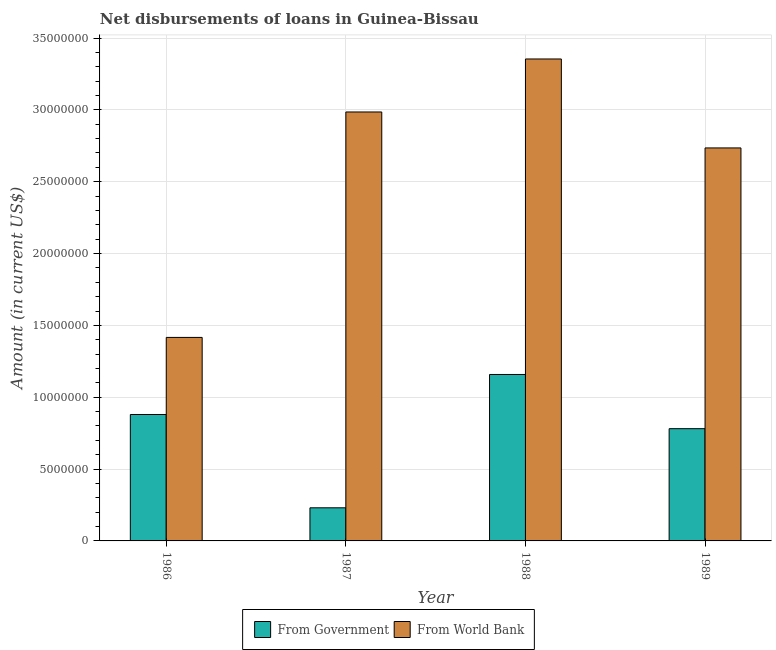Are the number of bars on each tick of the X-axis equal?
Provide a short and direct response. Yes. How many bars are there on the 4th tick from the left?
Your response must be concise. 2. How many bars are there on the 2nd tick from the right?
Give a very brief answer. 2. In how many cases, is the number of bars for a given year not equal to the number of legend labels?
Ensure brevity in your answer.  0. What is the net disbursements of loan from government in 1989?
Keep it short and to the point. 7.81e+06. Across all years, what is the maximum net disbursements of loan from world bank?
Your answer should be very brief. 3.35e+07. Across all years, what is the minimum net disbursements of loan from world bank?
Your answer should be compact. 1.42e+07. What is the total net disbursements of loan from government in the graph?
Your answer should be compact. 3.05e+07. What is the difference between the net disbursements of loan from government in 1987 and that in 1988?
Your answer should be compact. -9.28e+06. What is the difference between the net disbursements of loan from world bank in 1989 and the net disbursements of loan from government in 1986?
Make the answer very short. 1.32e+07. What is the average net disbursements of loan from government per year?
Provide a succinct answer. 7.62e+06. In the year 1987, what is the difference between the net disbursements of loan from world bank and net disbursements of loan from government?
Your answer should be compact. 0. In how many years, is the net disbursements of loan from world bank greater than 14000000 US$?
Your answer should be very brief. 4. What is the ratio of the net disbursements of loan from world bank in 1986 to that in 1989?
Make the answer very short. 0.52. Is the net disbursements of loan from world bank in 1986 less than that in 1988?
Offer a terse response. Yes. Is the difference between the net disbursements of loan from world bank in 1987 and 1989 greater than the difference between the net disbursements of loan from government in 1987 and 1989?
Make the answer very short. No. What is the difference between the highest and the second highest net disbursements of loan from world bank?
Provide a succinct answer. 3.69e+06. What is the difference between the highest and the lowest net disbursements of loan from government?
Give a very brief answer. 9.28e+06. In how many years, is the net disbursements of loan from government greater than the average net disbursements of loan from government taken over all years?
Make the answer very short. 3. Is the sum of the net disbursements of loan from world bank in 1987 and 1989 greater than the maximum net disbursements of loan from government across all years?
Ensure brevity in your answer.  Yes. What does the 1st bar from the left in 1989 represents?
Provide a succinct answer. From Government. What does the 2nd bar from the right in 1989 represents?
Provide a short and direct response. From Government. How many bars are there?
Ensure brevity in your answer.  8. Are all the bars in the graph horizontal?
Give a very brief answer. No. Where does the legend appear in the graph?
Ensure brevity in your answer.  Bottom center. How are the legend labels stacked?
Your answer should be compact. Horizontal. What is the title of the graph?
Offer a very short reply. Net disbursements of loans in Guinea-Bissau. What is the label or title of the Y-axis?
Offer a very short reply. Amount (in current US$). What is the Amount (in current US$) in From Government in 1986?
Offer a very short reply. 8.80e+06. What is the Amount (in current US$) in From World Bank in 1986?
Your response must be concise. 1.42e+07. What is the Amount (in current US$) of From Government in 1987?
Provide a succinct answer. 2.30e+06. What is the Amount (in current US$) of From World Bank in 1987?
Provide a short and direct response. 2.99e+07. What is the Amount (in current US$) of From Government in 1988?
Your answer should be very brief. 1.16e+07. What is the Amount (in current US$) in From World Bank in 1988?
Offer a terse response. 3.35e+07. What is the Amount (in current US$) in From Government in 1989?
Your answer should be compact. 7.81e+06. What is the Amount (in current US$) of From World Bank in 1989?
Your answer should be compact. 2.74e+07. Across all years, what is the maximum Amount (in current US$) of From Government?
Keep it short and to the point. 1.16e+07. Across all years, what is the maximum Amount (in current US$) of From World Bank?
Ensure brevity in your answer.  3.35e+07. Across all years, what is the minimum Amount (in current US$) of From Government?
Provide a short and direct response. 2.30e+06. Across all years, what is the minimum Amount (in current US$) of From World Bank?
Your answer should be very brief. 1.42e+07. What is the total Amount (in current US$) of From Government in the graph?
Give a very brief answer. 3.05e+07. What is the total Amount (in current US$) of From World Bank in the graph?
Give a very brief answer. 1.05e+08. What is the difference between the Amount (in current US$) of From Government in 1986 and that in 1987?
Ensure brevity in your answer.  6.49e+06. What is the difference between the Amount (in current US$) in From World Bank in 1986 and that in 1987?
Keep it short and to the point. -1.57e+07. What is the difference between the Amount (in current US$) of From Government in 1986 and that in 1988?
Keep it short and to the point. -2.79e+06. What is the difference between the Amount (in current US$) in From World Bank in 1986 and that in 1988?
Your answer should be very brief. -1.94e+07. What is the difference between the Amount (in current US$) of From Government in 1986 and that in 1989?
Provide a short and direct response. 9.87e+05. What is the difference between the Amount (in current US$) in From World Bank in 1986 and that in 1989?
Offer a very short reply. -1.32e+07. What is the difference between the Amount (in current US$) of From Government in 1987 and that in 1988?
Provide a succinct answer. -9.28e+06. What is the difference between the Amount (in current US$) of From World Bank in 1987 and that in 1988?
Ensure brevity in your answer.  -3.69e+06. What is the difference between the Amount (in current US$) of From Government in 1987 and that in 1989?
Keep it short and to the point. -5.51e+06. What is the difference between the Amount (in current US$) in From World Bank in 1987 and that in 1989?
Your response must be concise. 2.50e+06. What is the difference between the Amount (in current US$) of From Government in 1988 and that in 1989?
Offer a very short reply. 3.77e+06. What is the difference between the Amount (in current US$) in From World Bank in 1988 and that in 1989?
Give a very brief answer. 6.19e+06. What is the difference between the Amount (in current US$) of From Government in 1986 and the Amount (in current US$) of From World Bank in 1987?
Your answer should be compact. -2.11e+07. What is the difference between the Amount (in current US$) of From Government in 1986 and the Amount (in current US$) of From World Bank in 1988?
Your answer should be compact. -2.47e+07. What is the difference between the Amount (in current US$) in From Government in 1986 and the Amount (in current US$) in From World Bank in 1989?
Provide a short and direct response. -1.86e+07. What is the difference between the Amount (in current US$) in From Government in 1987 and the Amount (in current US$) in From World Bank in 1988?
Ensure brevity in your answer.  -3.12e+07. What is the difference between the Amount (in current US$) of From Government in 1987 and the Amount (in current US$) of From World Bank in 1989?
Offer a very short reply. -2.50e+07. What is the difference between the Amount (in current US$) in From Government in 1988 and the Amount (in current US$) in From World Bank in 1989?
Your answer should be compact. -1.58e+07. What is the average Amount (in current US$) of From Government per year?
Keep it short and to the point. 7.62e+06. What is the average Amount (in current US$) in From World Bank per year?
Your response must be concise. 2.62e+07. In the year 1986, what is the difference between the Amount (in current US$) of From Government and Amount (in current US$) of From World Bank?
Keep it short and to the point. -5.36e+06. In the year 1987, what is the difference between the Amount (in current US$) of From Government and Amount (in current US$) of From World Bank?
Keep it short and to the point. -2.75e+07. In the year 1988, what is the difference between the Amount (in current US$) in From Government and Amount (in current US$) in From World Bank?
Provide a succinct answer. -2.20e+07. In the year 1989, what is the difference between the Amount (in current US$) of From Government and Amount (in current US$) of From World Bank?
Your answer should be compact. -1.95e+07. What is the ratio of the Amount (in current US$) of From Government in 1986 to that in 1987?
Your answer should be compact. 3.82. What is the ratio of the Amount (in current US$) in From World Bank in 1986 to that in 1987?
Make the answer very short. 0.47. What is the ratio of the Amount (in current US$) in From Government in 1986 to that in 1988?
Your answer should be compact. 0.76. What is the ratio of the Amount (in current US$) in From World Bank in 1986 to that in 1988?
Your answer should be very brief. 0.42. What is the ratio of the Amount (in current US$) in From Government in 1986 to that in 1989?
Your answer should be compact. 1.13. What is the ratio of the Amount (in current US$) of From World Bank in 1986 to that in 1989?
Your response must be concise. 0.52. What is the ratio of the Amount (in current US$) in From Government in 1987 to that in 1988?
Your response must be concise. 0.2. What is the ratio of the Amount (in current US$) of From World Bank in 1987 to that in 1988?
Provide a short and direct response. 0.89. What is the ratio of the Amount (in current US$) in From Government in 1987 to that in 1989?
Your answer should be compact. 0.3. What is the ratio of the Amount (in current US$) of From World Bank in 1987 to that in 1989?
Your response must be concise. 1.09. What is the ratio of the Amount (in current US$) in From Government in 1988 to that in 1989?
Provide a short and direct response. 1.48. What is the ratio of the Amount (in current US$) in From World Bank in 1988 to that in 1989?
Provide a short and direct response. 1.23. What is the difference between the highest and the second highest Amount (in current US$) of From Government?
Keep it short and to the point. 2.79e+06. What is the difference between the highest and the second highest Amount (in current US$) of From World Bank?
Provide a succinct answer. 3.69e+06. What is the difference between the highest and the lowest Amount (in current US$) of From Government?
Your answer should be very brief. 9.28e+06. What is the difference between the highest and the lowest Amount (in current US$) in From World Bank?
Keep it short and to the point. 1.94e+07. 